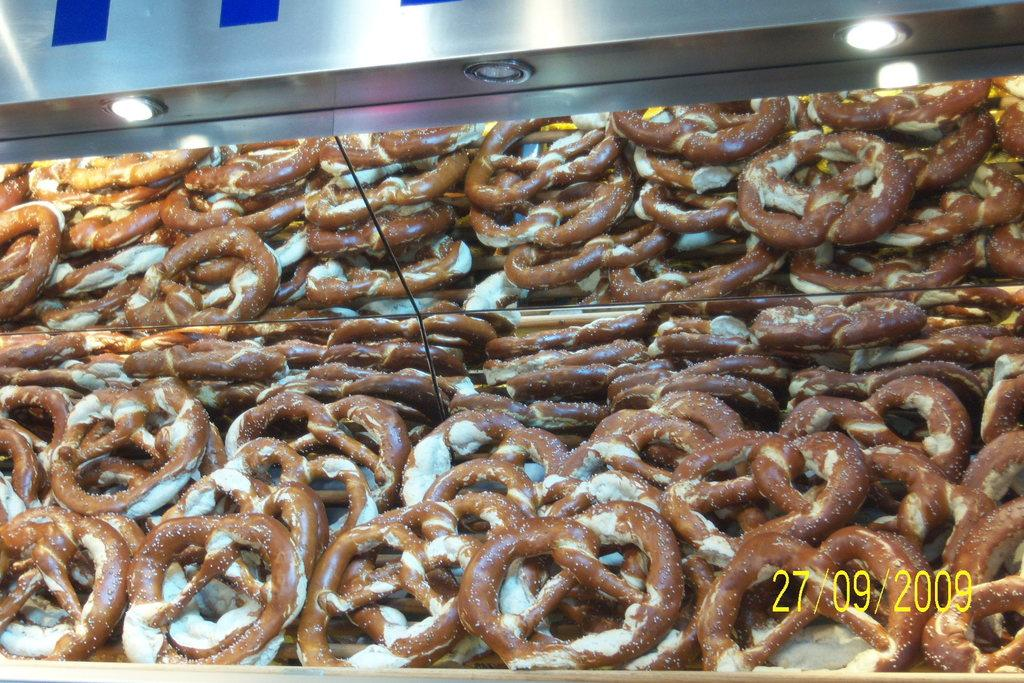What type of sweets can be seen in the image? There are many sweets rings in the image. Where are the sweets rings located? The sweets rings are placed in the front. What structure is visible in the image? There is a steel shed in the image. What feature is present on the steel shed? Spotlights are present on the steel shed. How many trains can be seen in the image? There are no trains present in the image. What is the scale of the sweets rings in the image? The scale of the sweets rings cannot be determined from the image alone, as there is no reference point for comparison. 